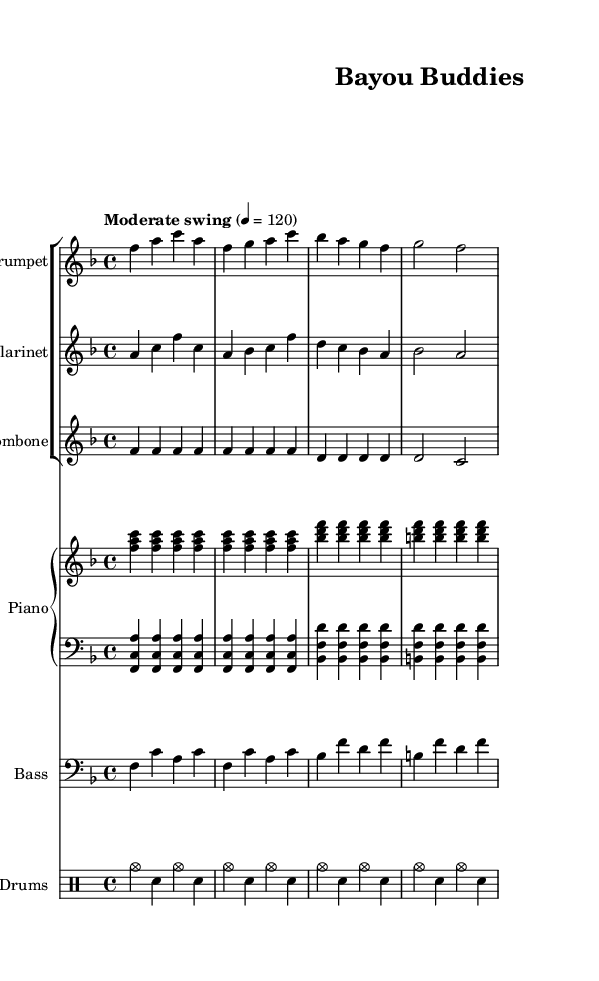What is the key signature of this music? The key signature is F major, which has one flat. This is identified by looking at the key signature at the beginning of the staff, which shows a flat symbol.
Answer: F major What is the time signature of this music? The time signature is 4/4, indicated at the beginning of the music, which tells how many beats are in each measure and what note gets the beat. In this case, there are four beats per measure.
Answer: 4/4 What is the tempo marking used in this piece? The tempo marking is "Moderate swing," which suggests a specific style and feel of the music. It's noted above the staff at the beginning and gives direction on how the piece should be played.
Answer: Moderate swing How many instruments are featured in this piece? There are five instruments listed, as indicated by the staff groups—Trumpet, Clarinet, Trombone, Piano, Bass, and Drums. Each type of instrument is notated at the beginning of their respective staves.
Answer: Five What is the main theme of this jazz piece? The theme focuses on friendship and loyalty, as suggested by the title "Bayou Buddies," which implies a sense of camaraderie and connection among friends. This theme is often reflected in the lyrical and melodic choices in New Orleans-style jazz.
Answer: Friendship and loyalty Which instrument plays the lowest notes? The Bass plays the lowest notes, indicated by the bass clef used for its staff, which is specifically designed for lower-range instruments. The pitch notation for the Bass shows lower sounds compared to the other instruments.
Answer: Bass 